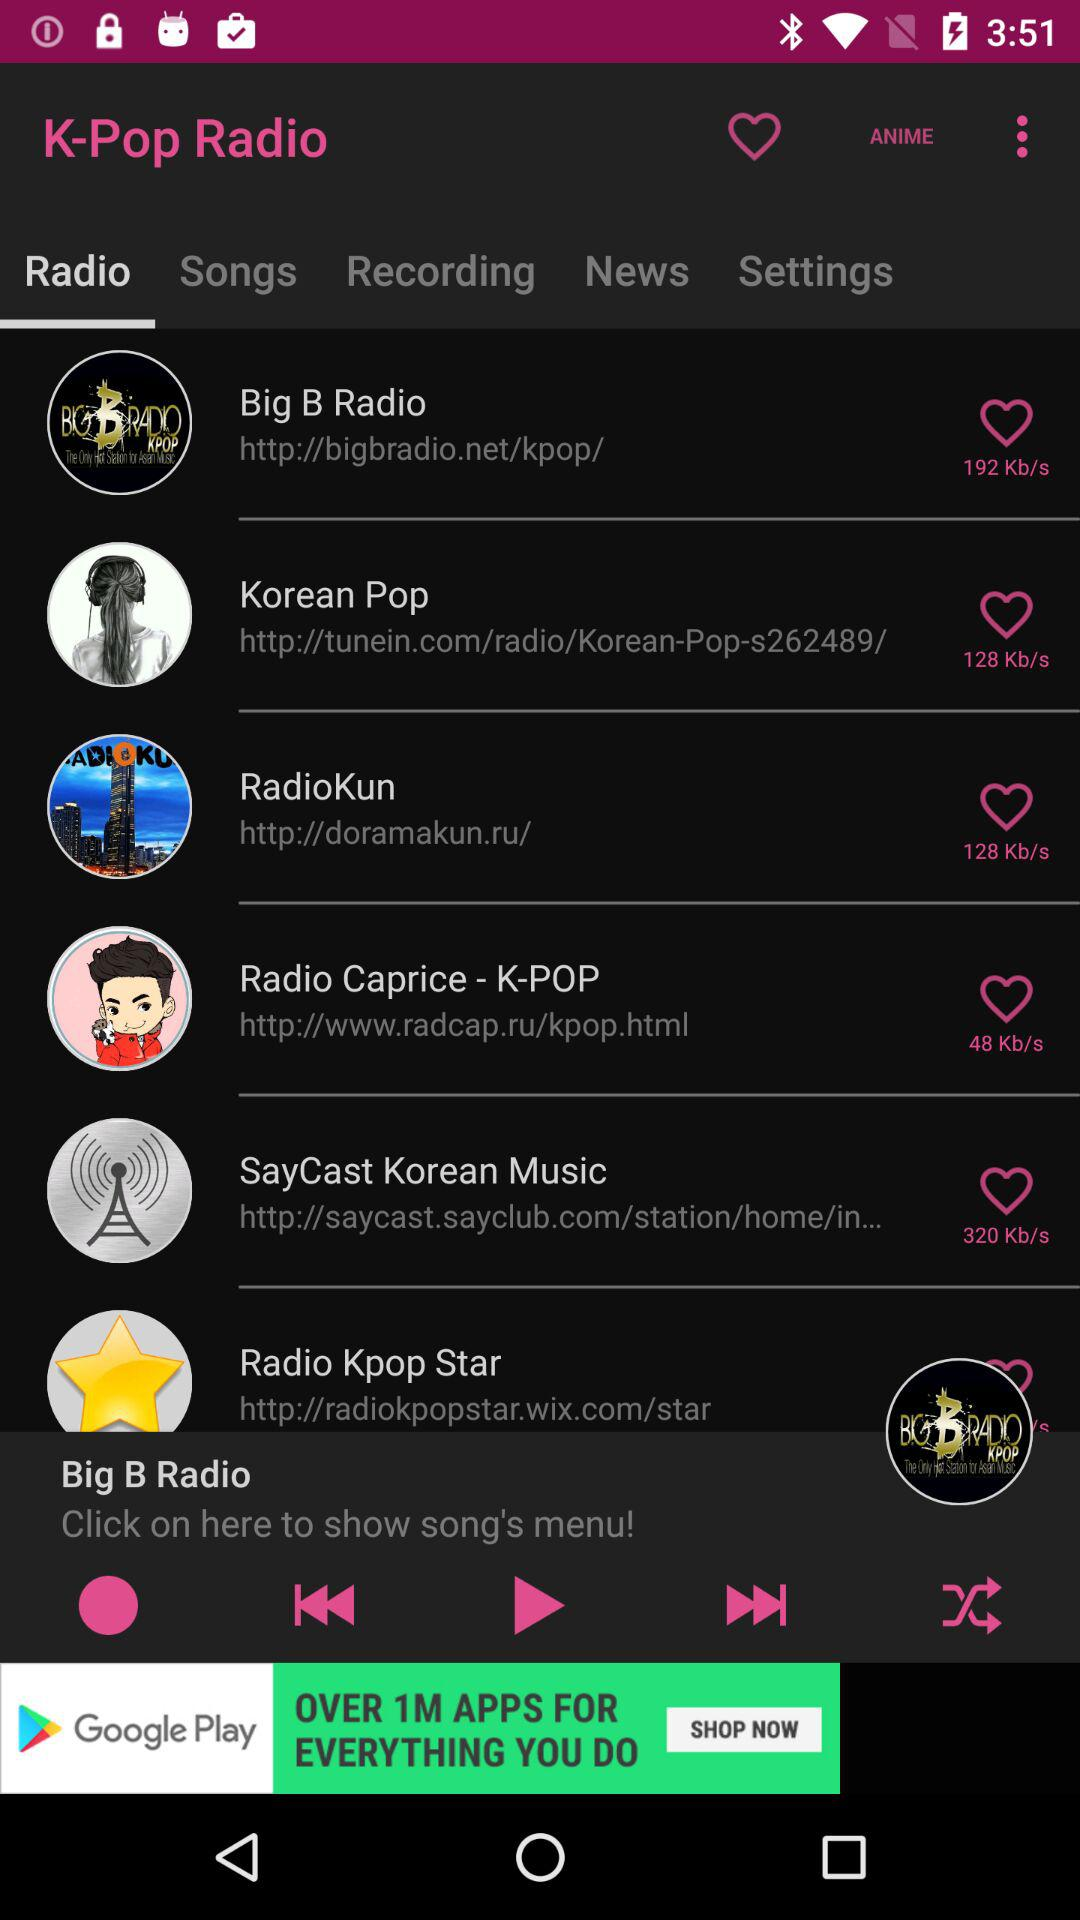Which audio was last played? The last played audio was "Big B Radio". 